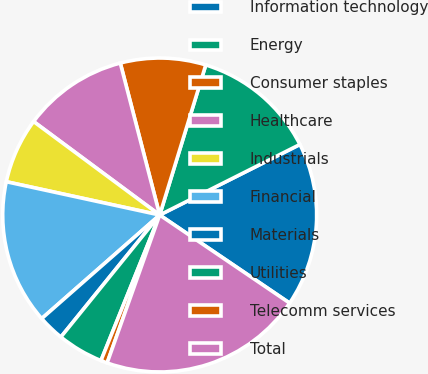Convert chart to OTSL. <chart><loc_0><loc_0><loc_500><loc_500><pie_chart><fcel>Information technology<fcel>Energy<fcel>Consumer staples<fcel>Healthcare<fcel>Industrials<fcel>Financial<fcel>Materials<fcel>Utilities<fcel>Telecomm services<fcel>Total<nl><fcel>16.9%<fcel>12.84%<fcel>8.78%<fcel>10.81%<fcel>6.75%<fcel>14.87%<fcel>2.7%<fcel>4.73%<fcel>0.67%<fcel>20.95%<nl></chart> 